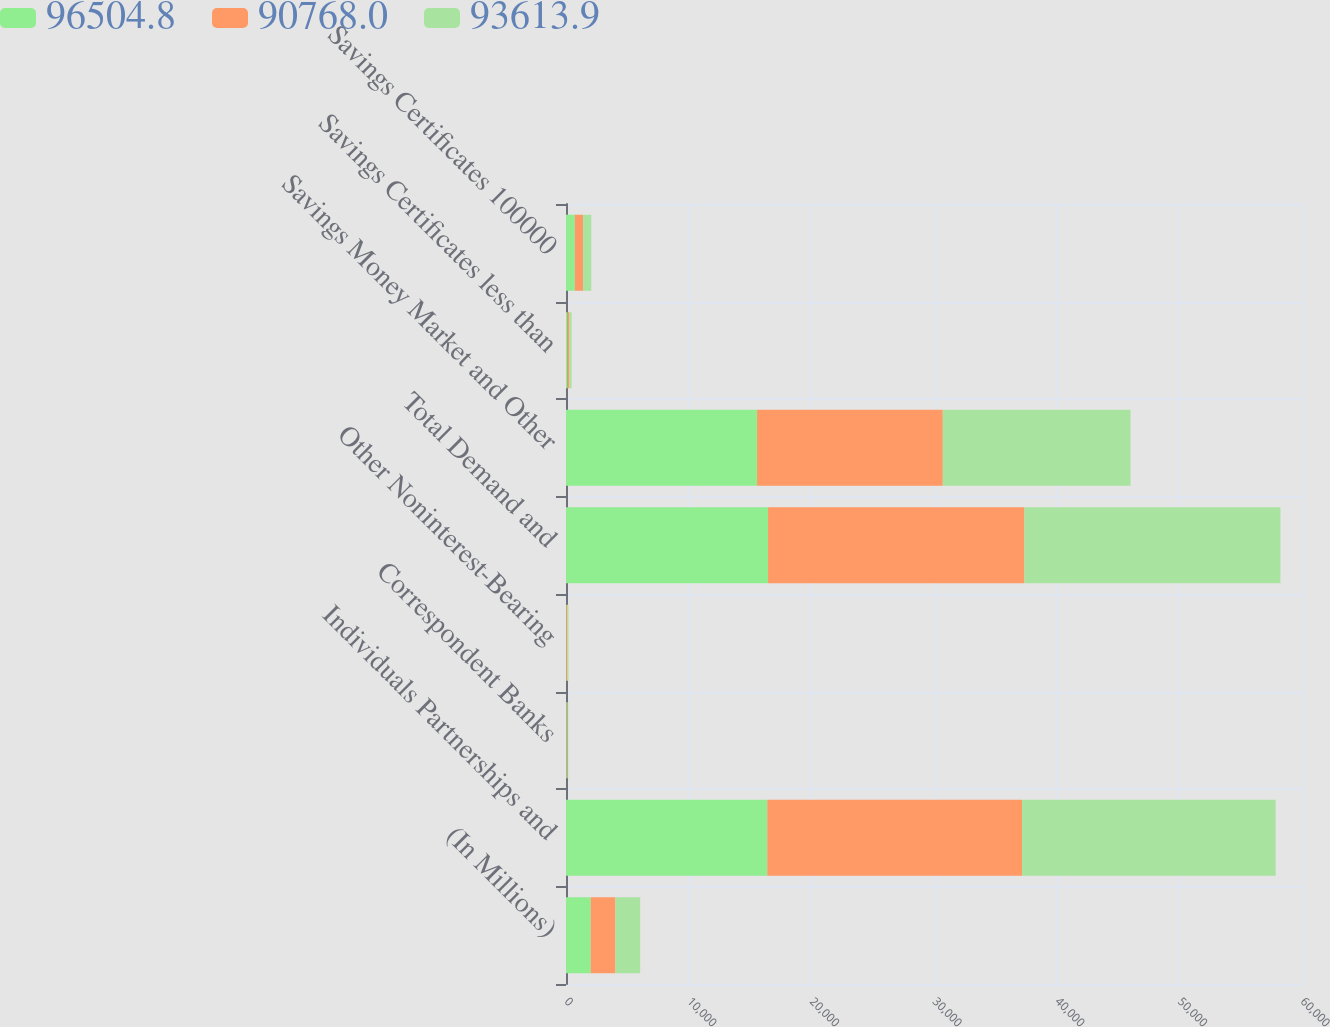Convert chart. <chart><loc_0><loc_0><loc_500><loc_500><stacked_bar_chart><ecel><fcel>(In Millions)<fcel>Individuals Partnerships and<fcel>Correspondent Banks<fcel>Other Noninterest-Bearing<fcel>Total Demand and<fcel>Savings Money Market and Other<fcel>Savings Certificates less than<fcel>Savings Certificates 100000<nl><fcel>96504.8<fcel>2017<fcel>16410.6<fcel>60.3<fcel>1.4<fcel>16472.3<fcel>15575.6<fcel>130.1<fcel>717.3<nl><fcel>90768<fcel>2016<fcel>20764.8<fcel>58<fcel>76.3<fcel>20899.1<fcel>15142.4<fcel>150.9<fcel>672<nl><fcel>93613.9<fcel>2015<fcel>20684.9<fcel>59.8<fcel>124.6<fcel>20869.3<fcel>15306.9<fcel>175.9<fcel>669.9<nl></chart> 